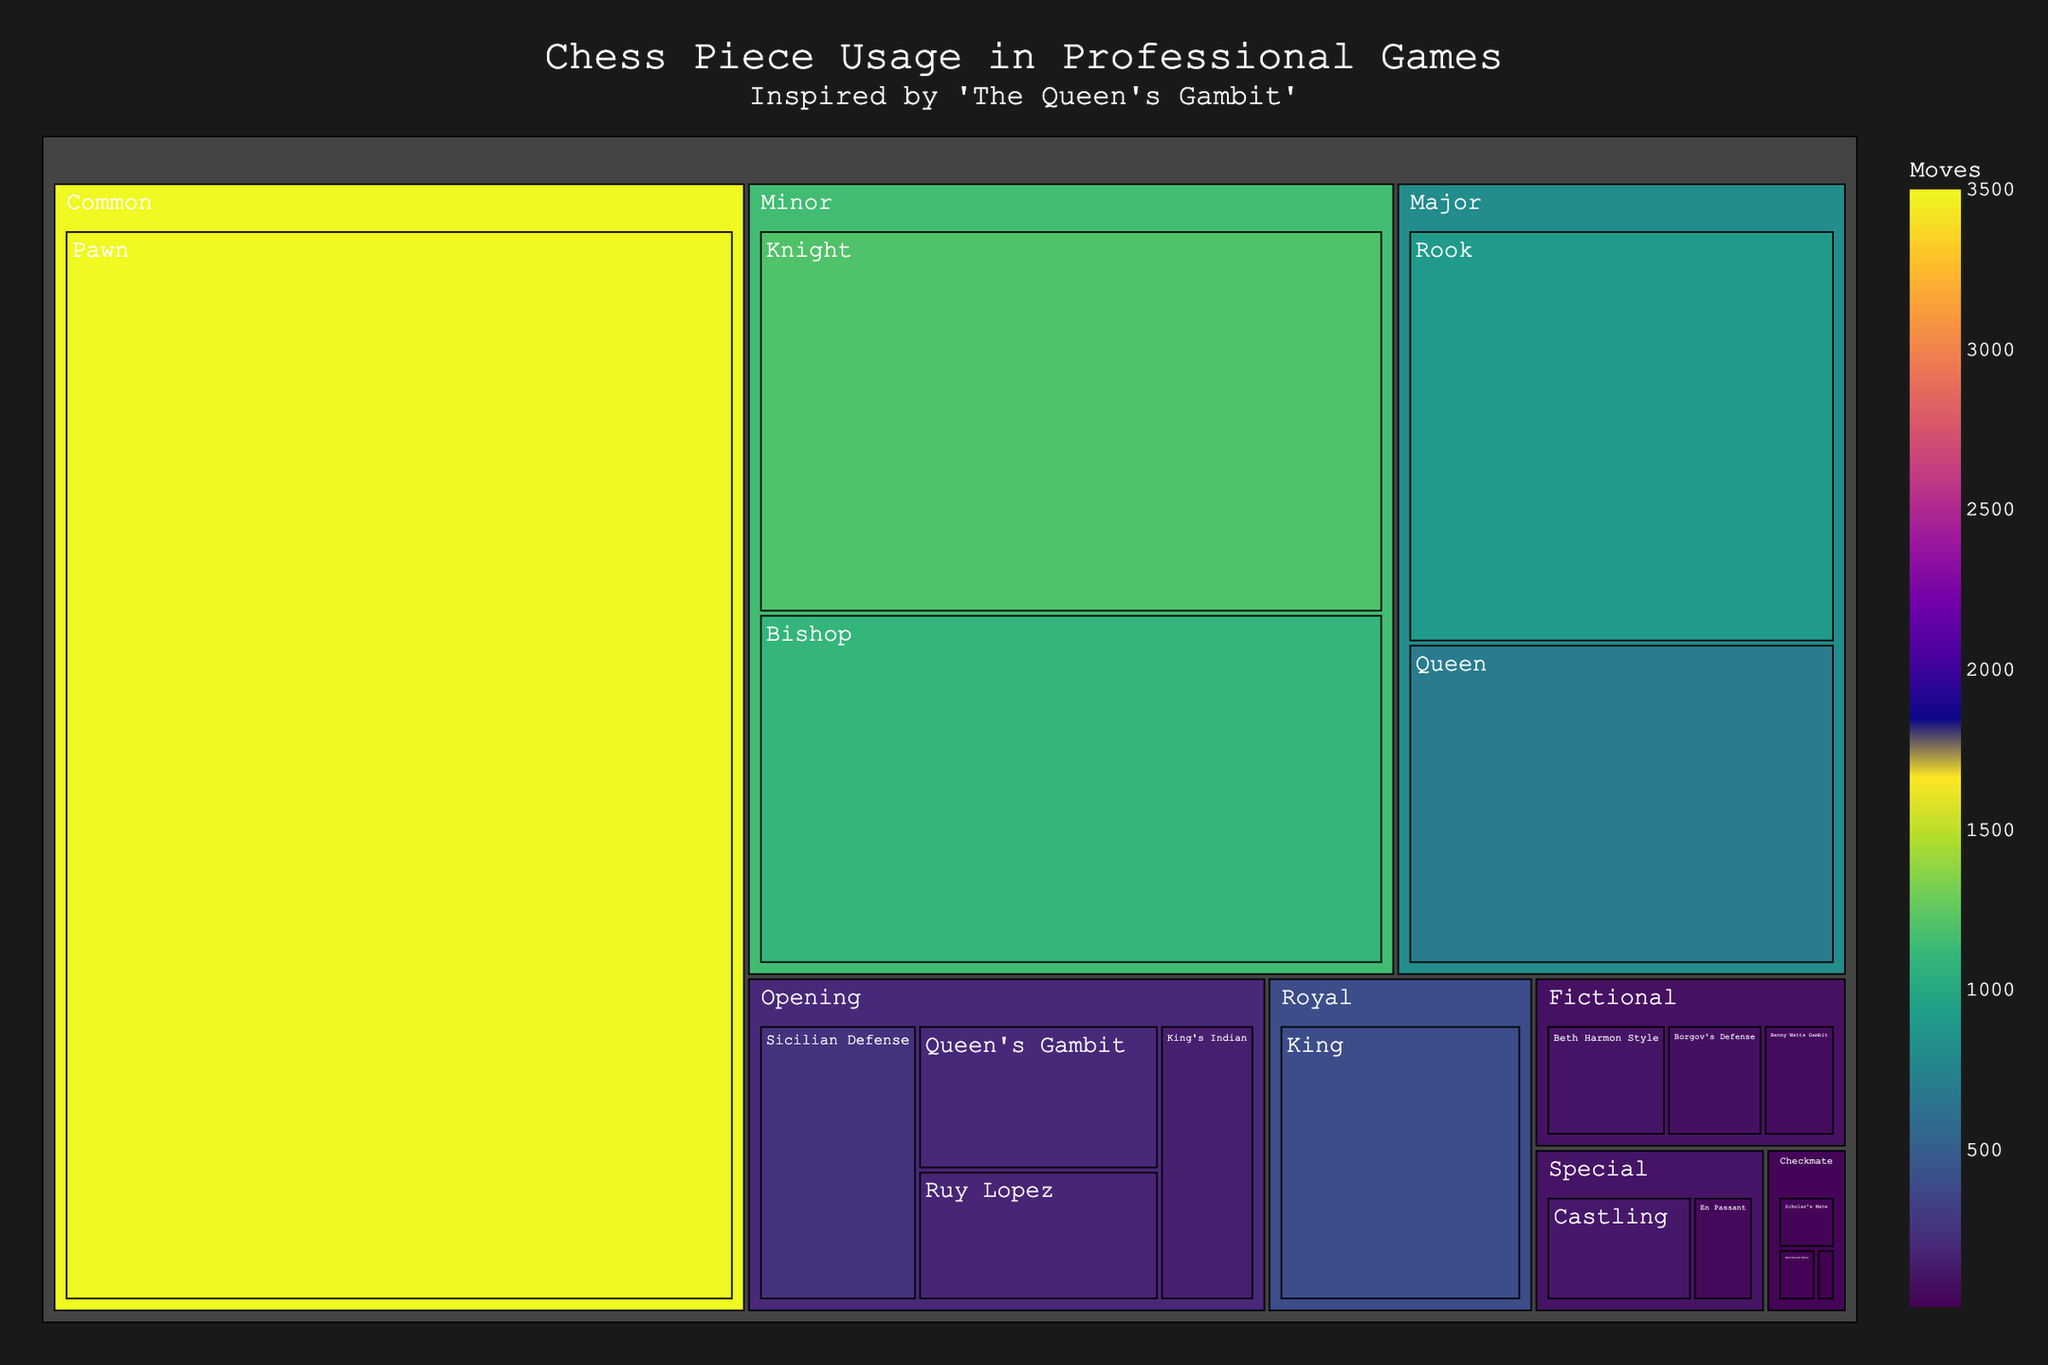Which chess piece category has the highest number of moves? By examining the treemap, we can see that the 'Common' category (Pawn) has the highest value in terms of move frequency, indicated by the largest area and highest color intensity in the plot.
Answer: Common Which checkmate type has the least number of moves? The treemap shows 'Fool's Mate' as the checkmate type with the smallest area and lowest color intensity among the checkmate types, indicating that it has the least number of moves.
Answer: Fool's Mate How many moves are made by major pieces in total? To find the total moves for major pieces, we sum the moves of the 'Rook' and 'Queen' within the 'Major' category. The Rook has 900 moves and the Queen has 700 moves, so the total is 900 + 700.
Answer: 1600 What is the difference in the number of moves between 'Pawn' and 'Knight'? The 'Pawn' has 3500 moves and the 'Knight' has 1200 moves. The difference is calculated by subtracting the Knight's moves from the Pawn's moves: 3500 - 1200.
Answer: 2300 Which opening has the highest number of moves? By examining the 'Opening' category, we can identify that 'Sicilian Defense' has the highest number of moves, indicated by the largest area and highest color intensity within its category.
Answer: Sicilian Defense What is the combined number of moves for 'King's Indian' and 'Ruy Lopez' openings? To find the combined number of moves, we add 'King's Indian' (150 moves) and 'Ruy Lopez' (180 moves). The total is 150 + 180.
Answer: 330 Which category has the piece 'Beth Harmon Style'? The treemap identifies 'Beth Harmon Style' under the 'Fictional' category, as represented in the fictional elements inspired by 'The Queen's Gambit'.
Answer: Fictional Compare the number of moves for 'Castling' and 'En Passant'. Which is greater and by how much? By examining the 'Special' category, 'Castling' has 120 moves, while 'En Passant' has 50 moves. To find out which is greater and by how much, we subtract 50 from 120: 120 - 50.
Answer: Castling, by 70 Which piece in the 'Minor' category has the highest number of moves? Within the 'Minor' category, the Knight has 1200 moves, while the Bishop has 1100. Therefore, the Knight has the highest number of moves in the Minor category.
Answer: Knight 